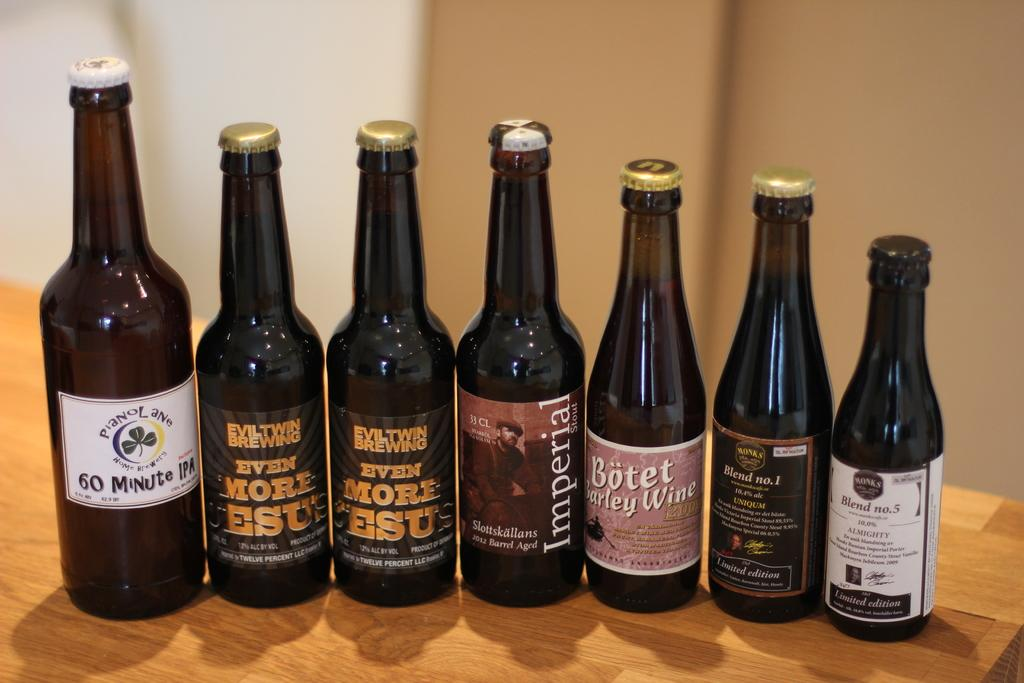What objects are on the table in the image? There are bottles on a table in the image. What can be seen in the background of the image? There is a wall visible in the background of the image. What type of hobbies are the bottles engaged in within the image? The bottles are inanimate objects and do not engage in hobbies. Is there any sleet visible in the image? There is no mention of sleet or any weather conditions in the image. 